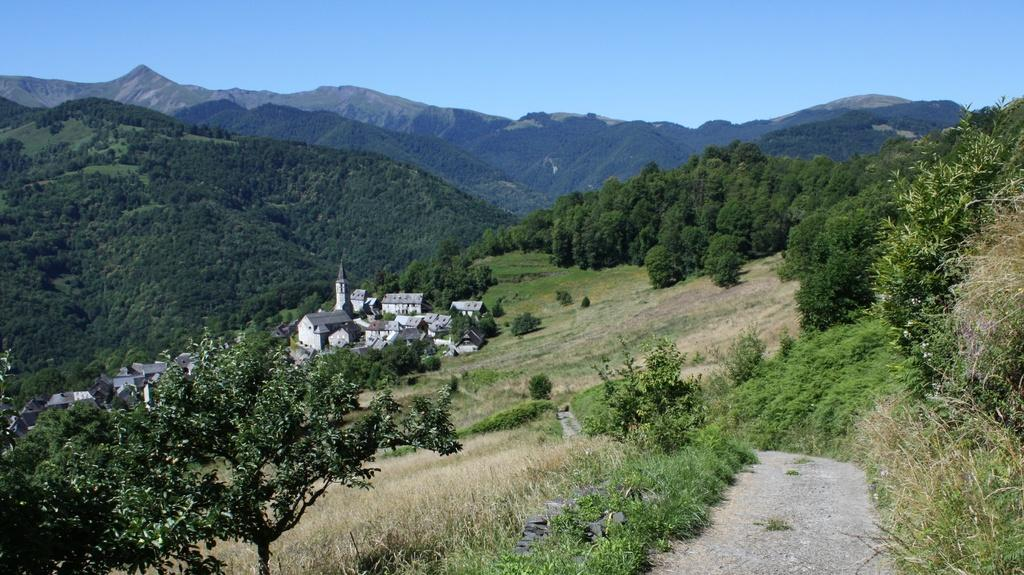What type of structures can be seen on the left side of the image? There are houses on the left side of the image. What can be observed in the surroundings of the area in the image? There is greenery around the area of the image. What type of yoke is being used by the governor in the image? There is no yoke or governor present in the image. What is the hope of the person in the image? There is no person present in the image, so it is impossible to determine their hope. 